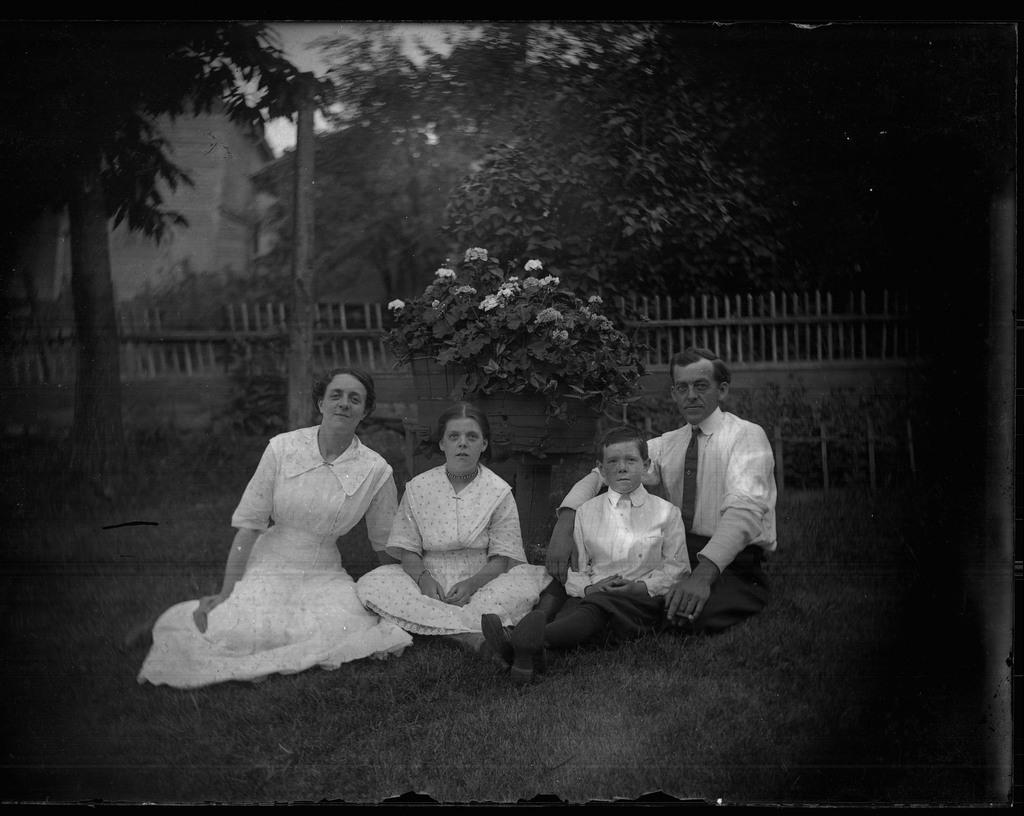What is the color scheme of the image? The image is black and white. How many people are sitting in the image? There are 4 people sitting in the image. What is located behind the people? There is a fencing behind the people. What can be seen beyond the fencing? Trees are visible behind the fencing. What type of bedroom furniture can be seen in the image? There is no bedroom furniture present in the image; it features 4 people sitting with a fencing and trees in the background. Can you tell me how many noses are visible in the image? There is no specific focus on noses in the image; it shows 4 people sitting with a fencing and trees in the background. 